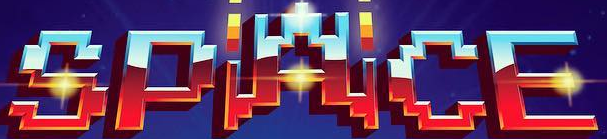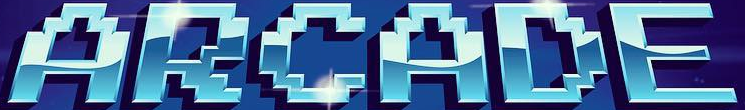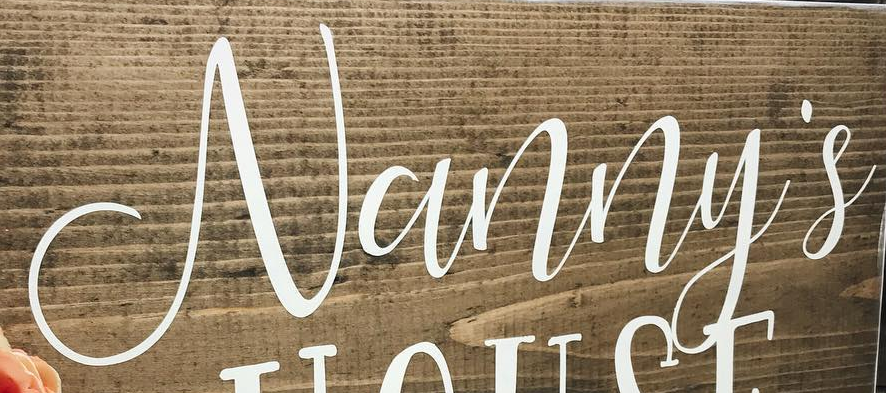Read the text from these images in sequence, separated by a semicolon. SPACE; ARCADE; Vanny's 